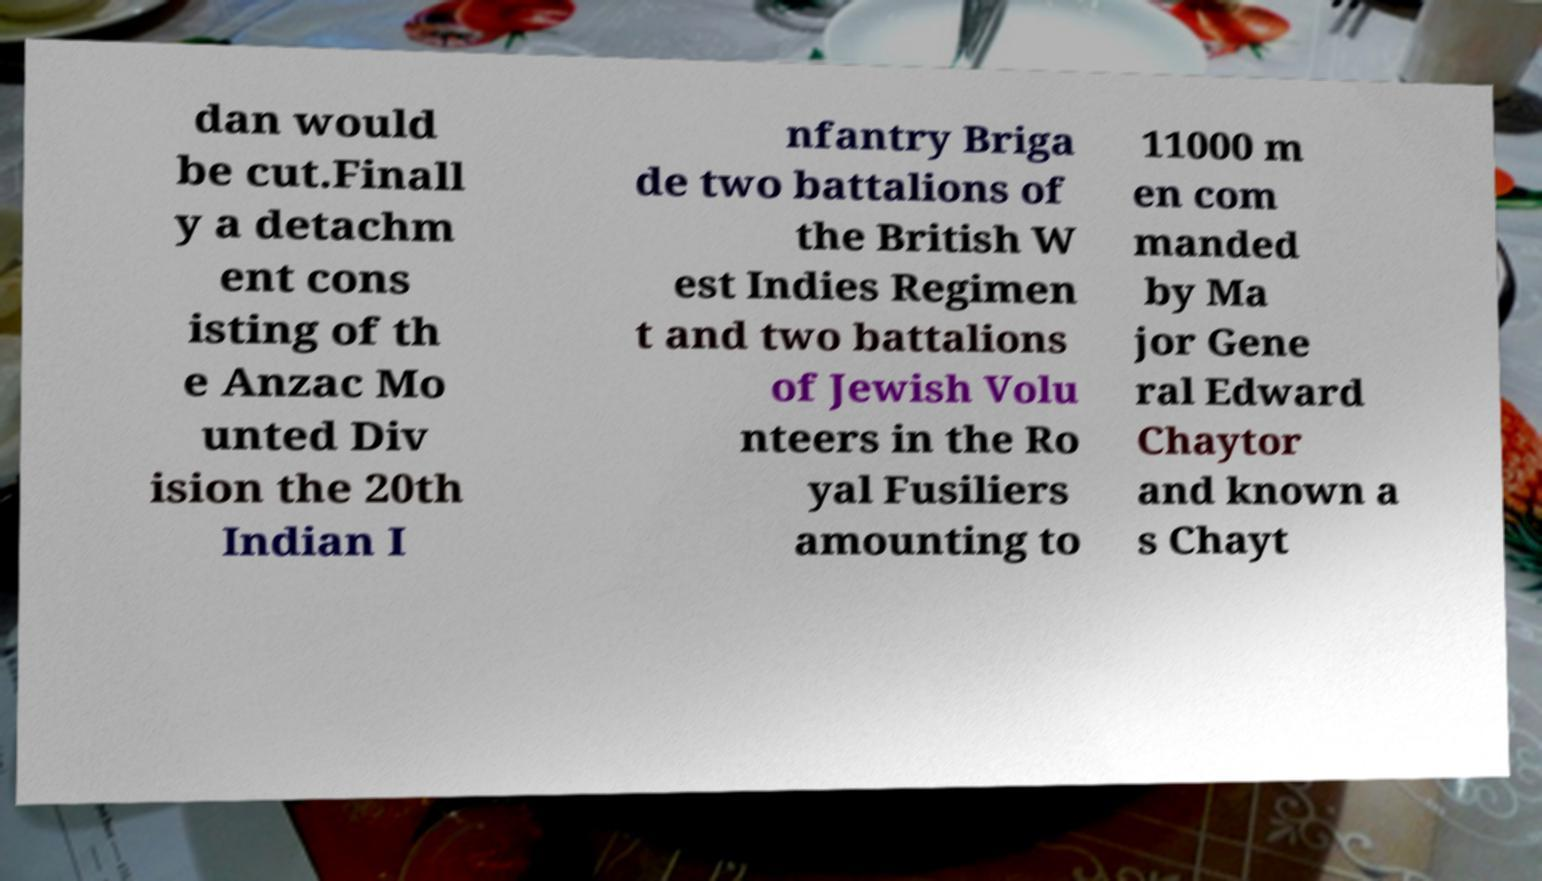For documentation purposes, I need the text within this image transcribed. Could you provide that? dan would be cut.Finall y a detachm ent cons isting of th e Anzac Mo unted Div ision the 20th Indian I nfantry Briga de two battalions of the British W est Indies Regimen t and two battalions of Jewish Volu nteers in the Ro yal Fusiliers amounting to 11000 m en com manded by Ma jor Gene ral Edward Chaytor and known a s Chayt 